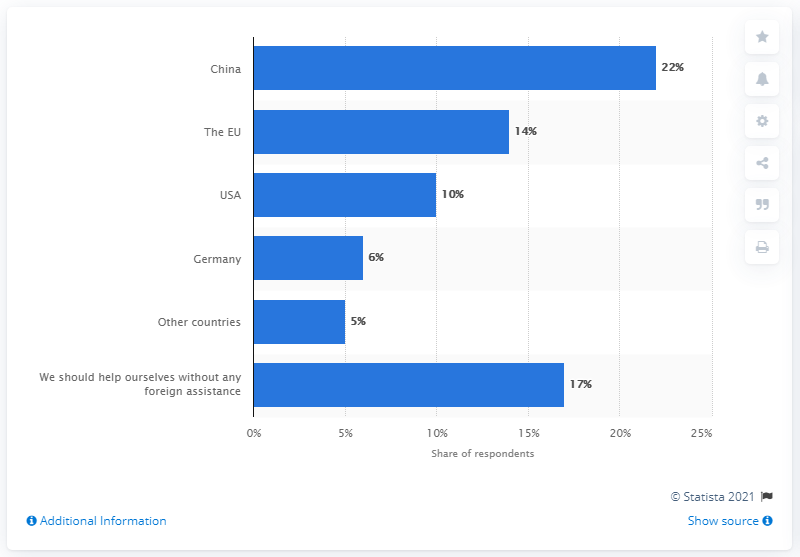Point out several critical features in this image. According to the survey, the majority of respondents anticipated receiving foreign aid from China, a country often criticized for its human rights record. 